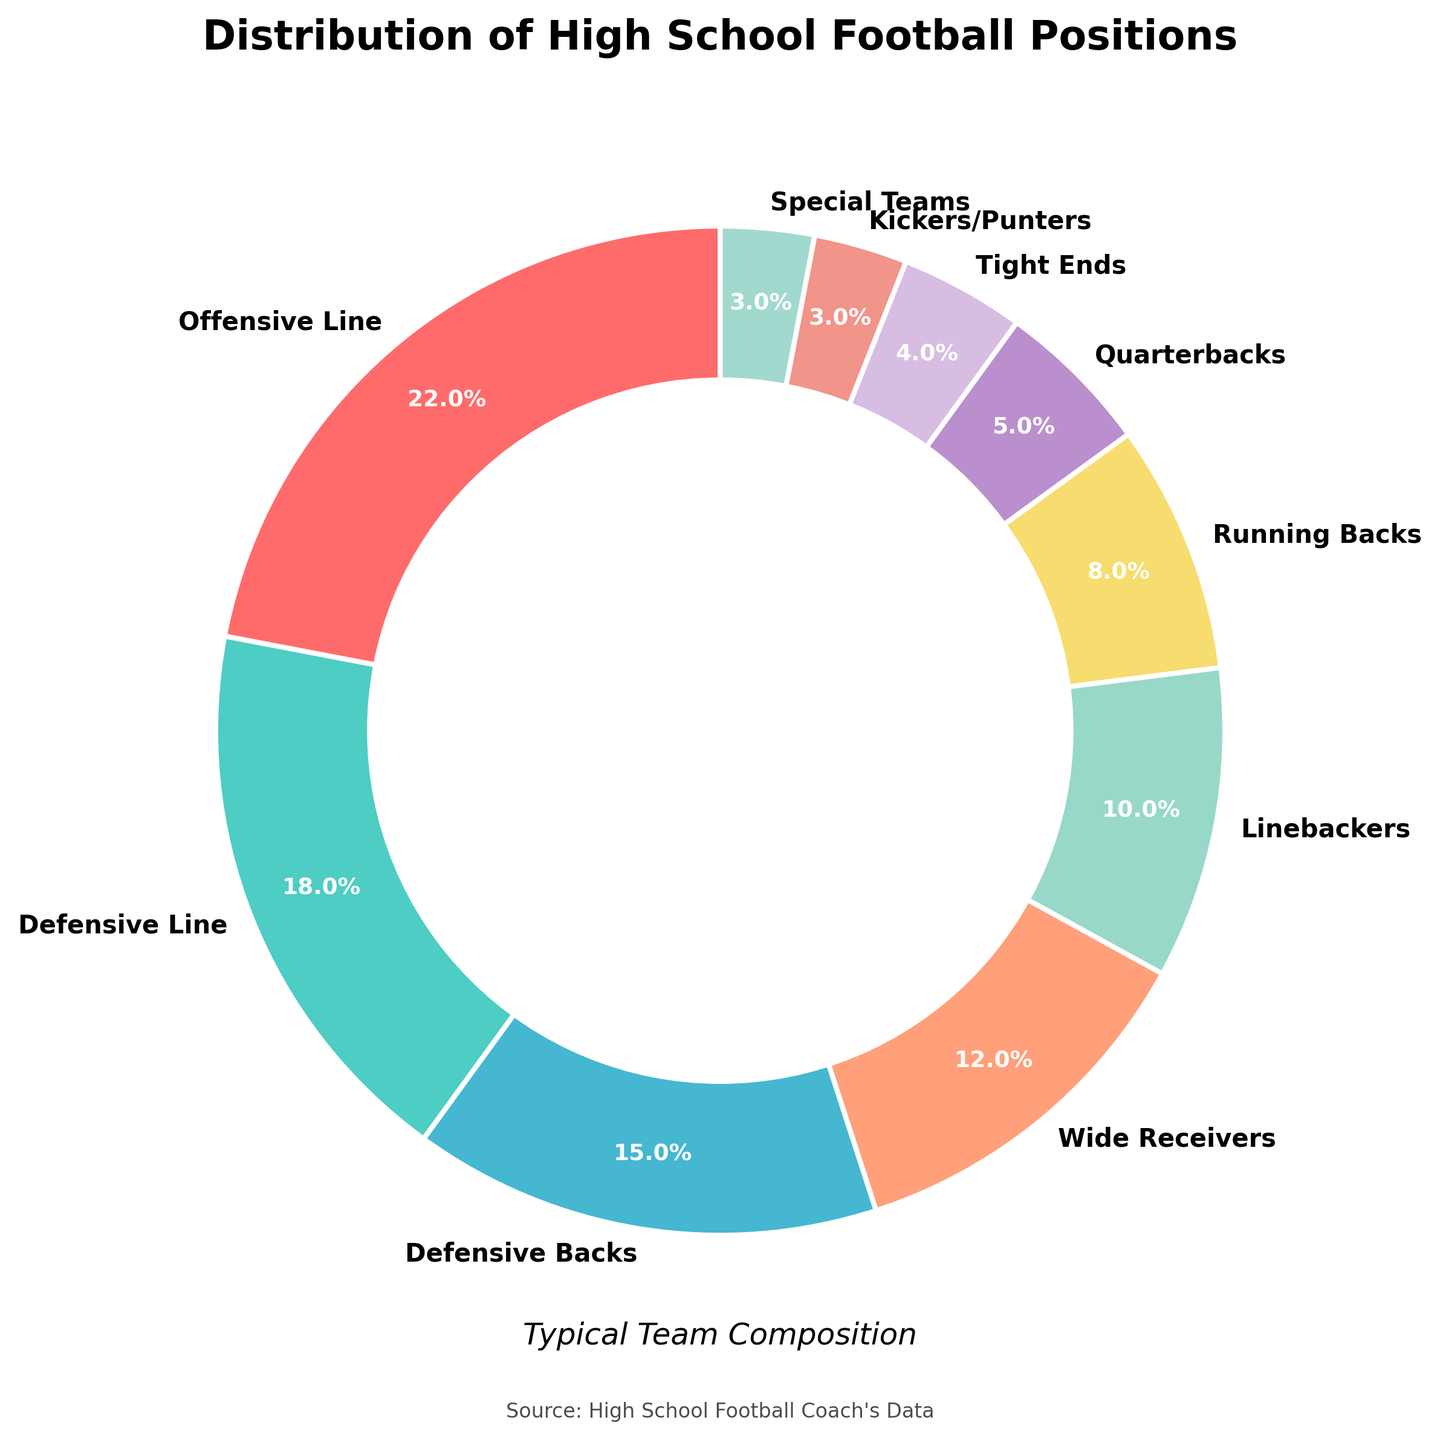What percentage of the team is composed of Offensive Line and Linebackers combined? The percentage of Offensive Line is 22% and the percentage of Linebackers is 10%. Adding these together, the combined percentage is 22% + 10% = 32%.
Answer: 32% Which position takes up a greater percentage of the team, Wide Receivers or Running Backs? Percentage of Wide Receivers is 12% and Running Backs is 8%. Comparing these, Wide Receivers take up a greater percentage.
Answer: Wide Receivers What is the total percentage for Quarterbacks, Tight Ends, Kickers/Punters, and Special Teams combined? Adding the percentages for Quarterbacks (5%), Tight Ends (4%), Kickers/Punters (3%), and Special Teams (3%) results in 5% + 4% + 3% + 3% = 15%.
Answer: 15% Which position appears in blue? Based on the pie chart's color scheme, Tight Ends are in blue.
Answer: Tight Ends How many positions have percentages greater than 10%? The positions with percentages greater than 10% are Offensive Line (22%), Defensive Line (18%), Defensive Backs (15%), and Wide Receivers (12%). This makes a total of four positions.
Answer: 4 What percentage of the team is composed of positions that have less than 10% each? Adding the percentages of positions with less than 10%: Running Backs (8%), Quarterbacks (5%), Tight Ends (4%), Kickers/Punters (3%), and Special Teams (3%). This sums up to 8% + 5% + 4% + 3% + 3% = 23%.
Answer: 23% How does the percentage of Defensive Line compare to the percentage of Offensive Line? The percentage of Defensive Line is 18%, while Offensive Line is 22%. The Offensive Line percentage is greater.
Answer: Offensive Line is greater Which position has the smallest proportion in the team? Both Kickers/Punters and Special Teams have the smallest proportion at 3% each.
Answer: Kickers/Punters and Special Teams What is the difference in percentage between Defensive Backs and Linebackers? Subtracting the percentage of Linebackers (10%) from Defensive Backs (15%): 15% - 10% = 5%.
Answer: 5% Which position takes up more than one-fifth of the team? The Offensive Line makes up 22%, which is more than one-fifth (20%) of the team.
Answer: Offensive Line 